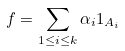<formula> <loc_0><loc_0><loc_500><loc_500>f = \sum _ { 1 \leq i \leq k } \alpha _ { i } 1 _ { A _ { i } }</formula> 